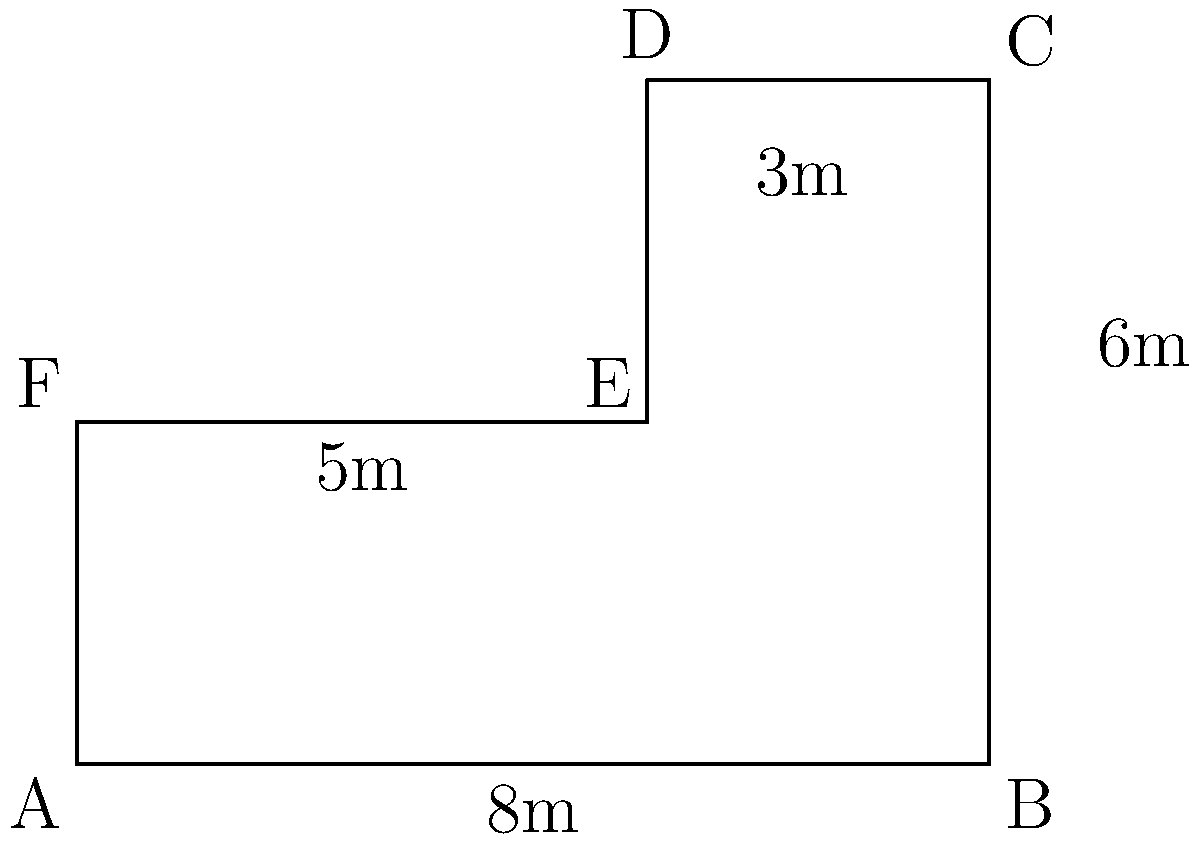You have an irregularly shaped farm plot for cultivating botanical ingredients. The plot can be divided into a rectangle and a trapezoid as shown in the diagram. What is the total area of the farm plot in square meters? To calculate the total area, we'll divide the plot into two parts and calculate their areas separately:

1. Rectangle ABEF:
   Length = 8m, Width = 3m
   Area of rectangle = $8 \times 3 = 24$ m²

2. Trapezoid BCDE:
   The area of a trapezoid is given by the formula: $A = \frac{1}{2}(b_1 + b_2)h$
   Where $b_1$ and $b_2$ are the parallel sides and $h$ is the height.
   
   Here, $b_1 = 8$m (BC), $b_2 = 5$m (DE), and $h = 3$m (height of trapezoid)
   
   Area of trapezoid = $\frac{1}{2}(8 + 5) \times 3 = \frac{13}{2} \times 3 = 19.5$ m²

3. Total area:
   Total area = Area of rectangle + Area of trapezoid
               = $24 + 19.5 = 43.5$ m²

Therefore, the total area of the farm plot is 43.5 square meters.
Answer: 43.5 m² 